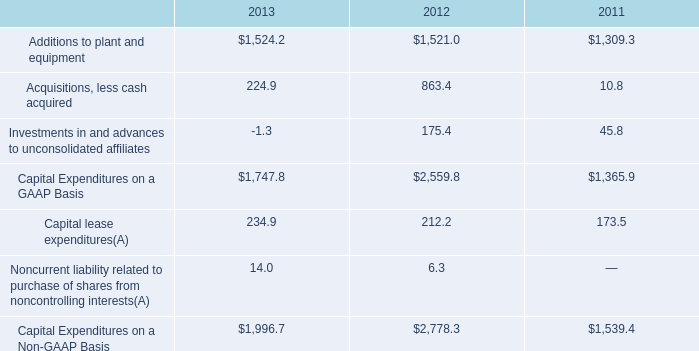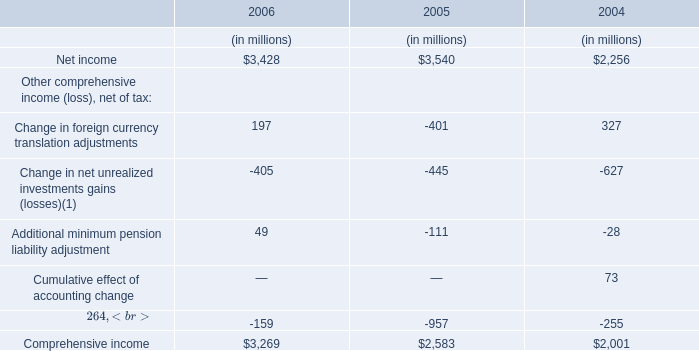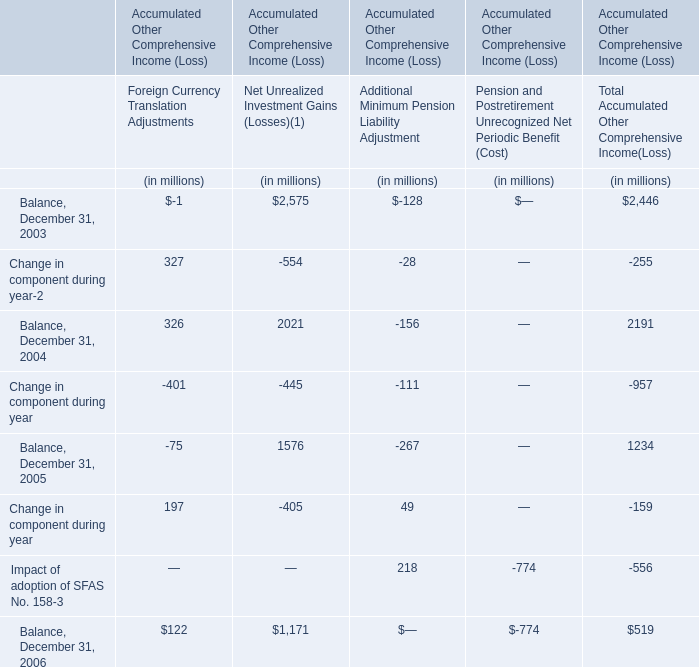What will Net income reach in 2007 if it continues to grow at the same growth rate in 2006? (in million) 
Computations: (3428 * (1 + ((3428 - 3540) / 3540)))
Answer: 3319.5435. 